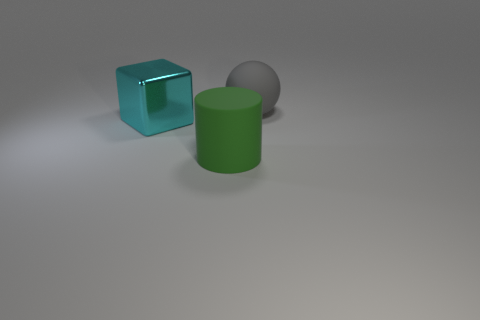Add 2 big cyan shiny cylinders. How many objects exist? 5 Subtract all spheres. How many objects are left? 2 Add 1 large cyan things. How many large cyan things are left? 2 Add 3 purple spheres. How many purple spheres exist? 3 Subtract 0 blue spheres. How many objects are left? 3 Subtract all spheres. Subtract all cyan cubes. How many objects are left? 1 